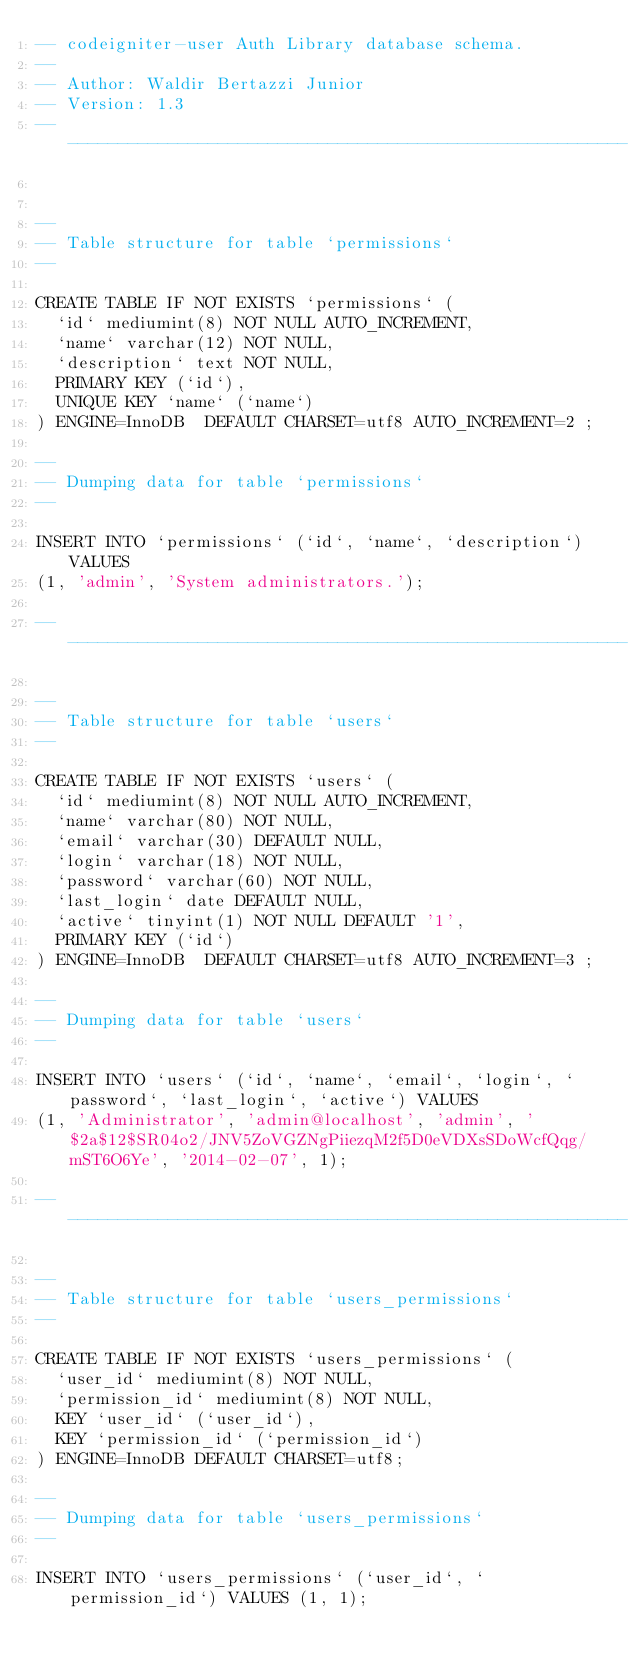Convert code to text. <code><loc_0><loc_0><loc_500><loc_500><_SQL_>-- codeigniter-user Auth Library database schema.
--
-- Author: Waldir Bertazzi Junior
-- Version: 1.3
-- --------------------------------------------------------


--
-- Table structure for table `permissions`
--

CREATE TABLE IF NOT EXISTS `permissions` (
  `id` mediumint(8) NOT NULL AUTO_INCREMENT,
  `name` varchar(12) NOT NULL,
  `description` text NOT NULL,
  PRIMARY KEY (`id`),
  UNIQUE KEY `name` (`name`)
) ENGINE=InnoDB  DEFAULT CHARSET=utf8 AUTO_INCREMENT=2 ;

--
-- Dumping data for table `permissions`
--

INSERT INTO `permissions` (`id`, `name`, `description`) VALUES
(1, 'admin', 'System administrators.');

-- --------------------------------------------------------

--
-- Table structure for table `users`
--

CREATE TABLE IF NOT EXISTS `users` (
  `id` mediumint(8) NOT NULL AUTO_INCREMENT,
  `name` varchar(80) NOT NULL,
  `email` varchar(30) DEFAULT NULL,
  `login` varchar(18) NOT NULL,
  `password` varchar(60) NOT NULL,
  `last_login` date DEFAULT NULL,
  `active` tinyint(1) NOT NULL DEFAULT '1',
  PRIMARY KEY (`id`)
) ENGINE=InnoDB  DEFAULT CHARSET=utf8 AUTO_INCREMENT=3 ;

--
-- Dumping data for table `users`
--

INSERT INTO `users` (`id`, `name`, `email`, `login`, `password`, `last_login`, `active`) VALUES
(1, 'Administrator', 'admin@localhost', 'admin', '$2a$12$SR04o2/JNV5ZoVGZNgPiiezqM2f5D0eVDXsSDoWcfQqg/mST6O6Ye', '2014-02-07', 1);

-- --------------------------------------------------------

--
-- Table structure for table `users_permissions`
--

CREATE TABLE IF NOT EXISTS `users_permissions` (
  `user_id` mediumint(8) NOT NULL,
  `permission_id` mediumint(8) NOT NULL,
  KEY `user_id` (`user_id`),
  KEY `permission_id` (`permission_id`)
) ENGINE=InnoDB DEFAULT CHARSET=utf8;

--
-- Dumping data for table `users_permissions`
--

INSERT INTO `users_permissions` (`user_id`, `permission_id`) VALUES (1, 1);</code> 